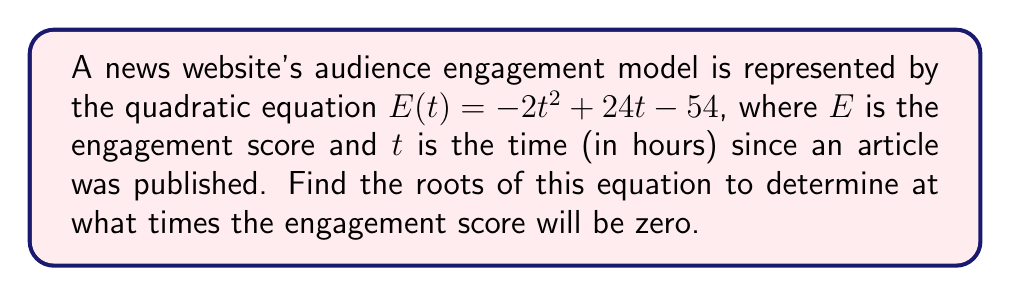Give your solution to this math problem. To find the roots of the quadratic equation, we need to solve $E(t) = 0$:

1) Set the equation equal to zero:
   $-2t^2 + 24t - 54 = 0$

2) This is in the standard form $at^2 + bt + c = 0$, where:
   $a = -2$, $b = 24$, and $c = -54$

3) We can use the quadratic formula: $t = \frac{-b \pm \sqrt{b^2 - 4ac}}{2a}$

4) Substituting our values:
   $t = \frac{-24 \pm \sqrt{24^2 - 4(-2)(-54)}}{2(-2)}$

5) Simplify under the square root:
   $t = \frac{-24 \pm \sqrt{576 - 432}}{-4} = \frac{-24 \pm \sqrt{144}}{-4}$

6) Simplify the square root:
   $t = \frac{-24 \pm 12}{-4}$

7) This gives us two equations:
   $t = \frac{-24 + 12}{-4}$ and $t = \frac{-24 - 12}{-4}$

8) Simplify:
   $t = \frac{-12}{-4} = 3$ and $t = \frac{-36}{-4} = 9$

Therefore, the engagement score will be zero at 3 hours and 9 hours after the article is published.
Answer: The roots of the equation are $t = 3$ and $t = 9$. 